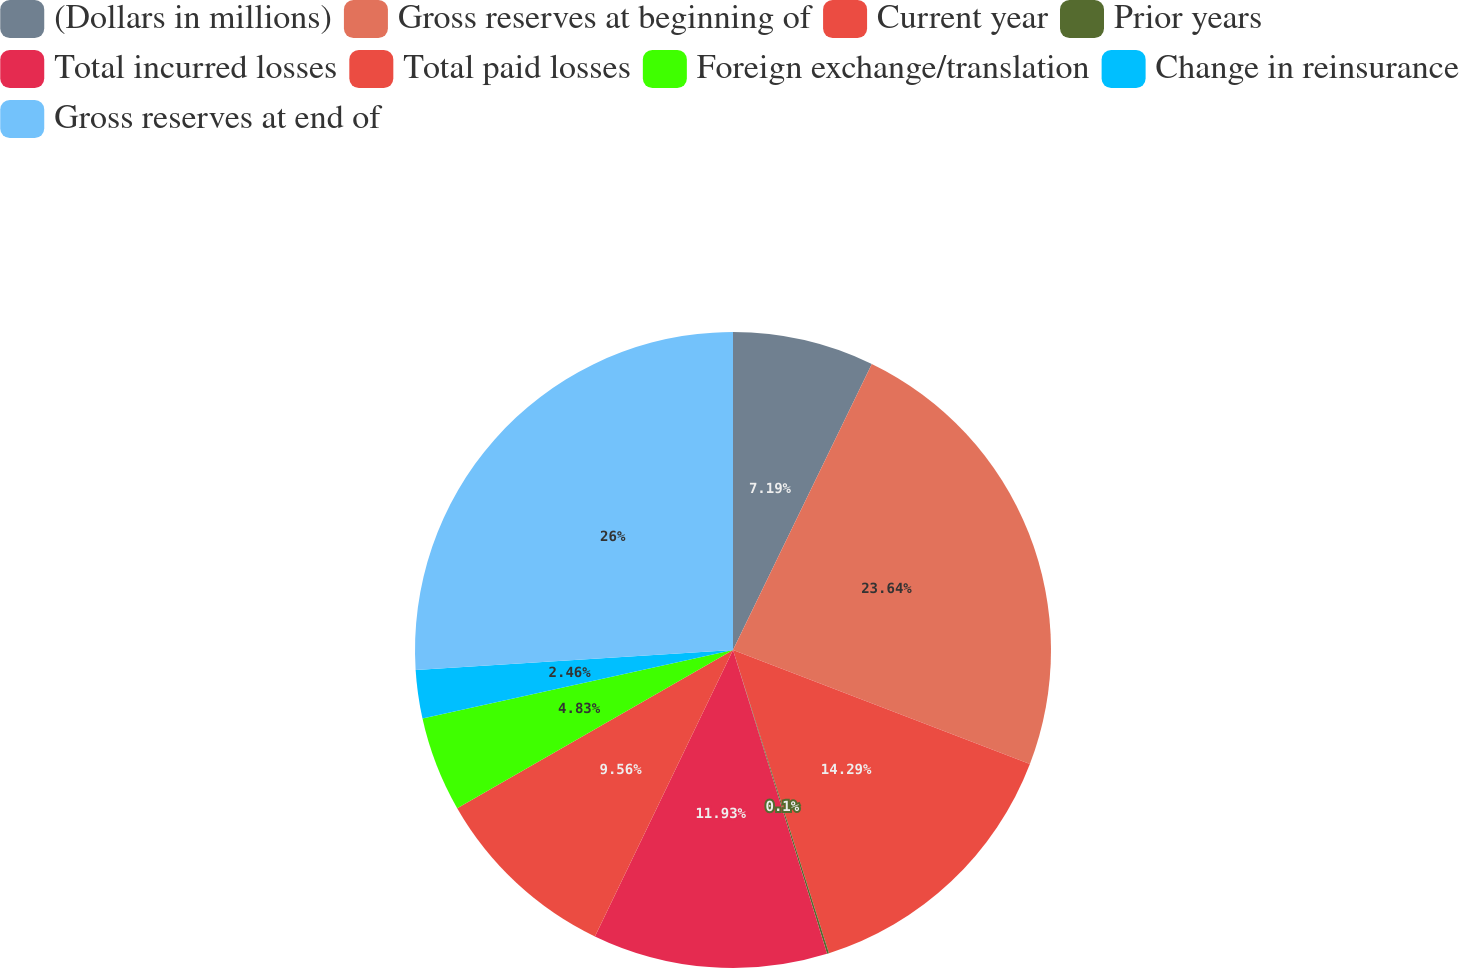Convert chart to OTSL. <chart><loc_0><loc_0><loc_500><loc_500><pie_chart><fcel>(Dollars in millions)<fcel>Gross reserves at beginning of<fcel>Current year<fcel>Prior years<fcel>Total incurred losses<fcel>Total paid losses<fcel>Foreign exchange/translation<fcel>Change in reinsurance<fcel>Gross reserves at end of<nl><fcel>7.19%<fcel>23.64%<fcel>14.29%<fcel>0.1%<fcel>11.93%<fcel>9.56%<fcel>4.83%<fcel>2.46%<fcel>26.0%<nl></chart> 